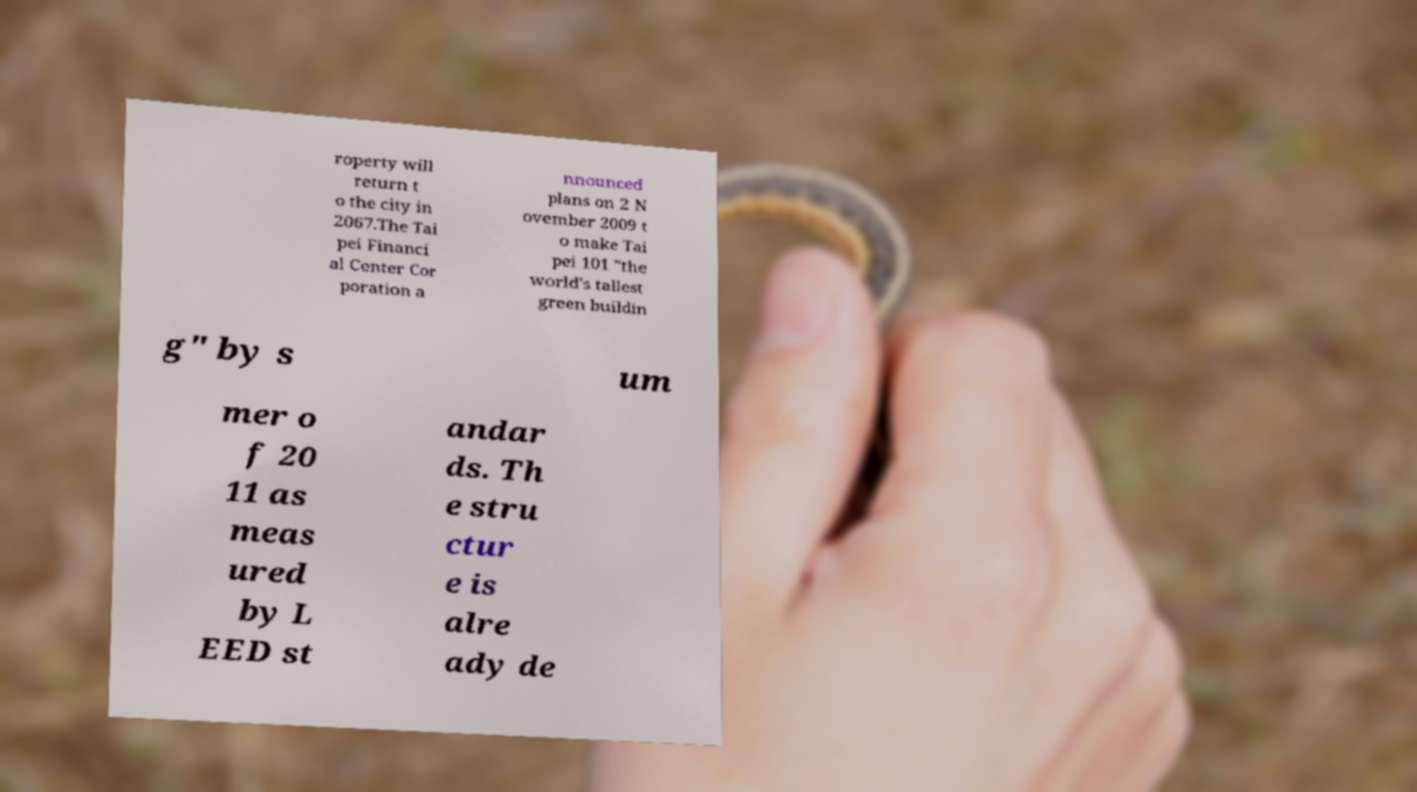What messages or text are displayed in this image? I need them in a readable, typed format. roperty will return t o the city in 2067.The Tai pei Financi al Center Cor poration a nnounced plans on 2 N ovember 2009 t o make Tai pei 101 "the world's tallest green buildin g" by s um mer o f 20 11 as meas ured by L EED st andar ds. Th e stru ctur e is alre ady de 